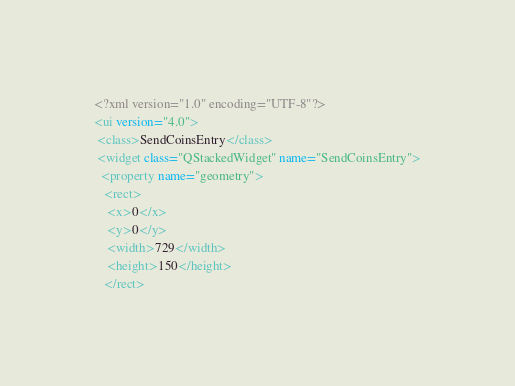Convert code to text. <code><loc_0><loc_0><loc_500><loc_500><_XML_><?xml version="1.0" encoding="UTF-8"?>
<ui version="4.0">
 <class>SendCoinsEntry</class>
 <widget class="QStackedWidget" name="SendCoinsEntry">
  <property name="geometry">
   <rect>
    <x>0</x>
    <y>0</y>
    <width>729</width>
    <height>150</height>
   </rect></code> 